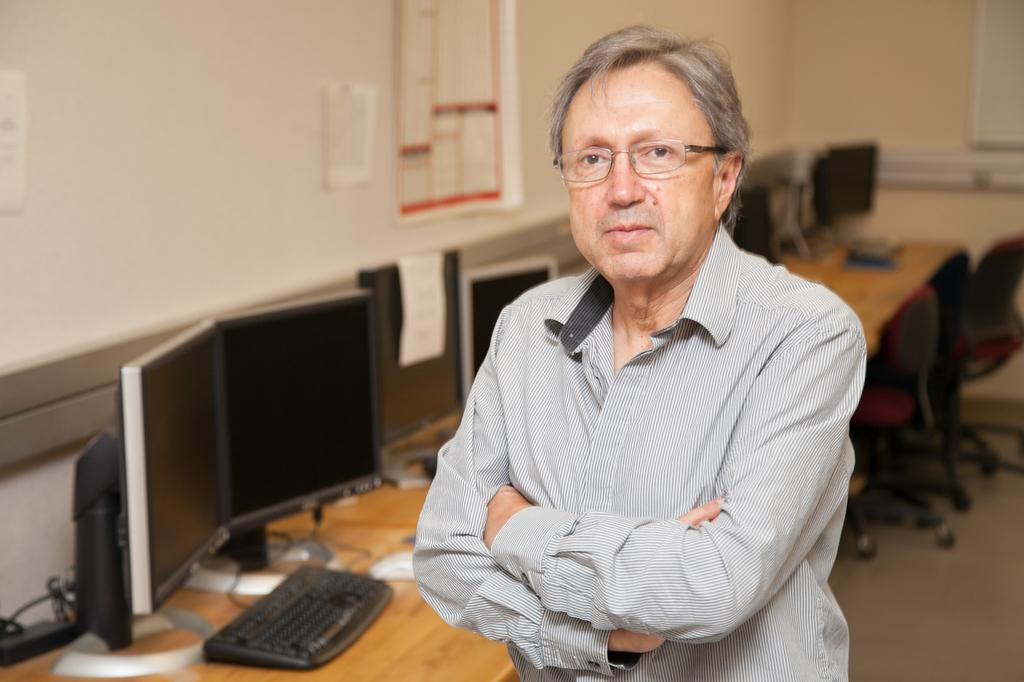What are the people in the image doing? The persons standing on the floor are likely working or interacting with the equipment in the background. What type of equipment can be seen in the background? Monitors, keyboards, tables, chairs, and a board are visible in the background. What type of wall decoration is present in the background? There is a calendar on the wall in the background. Can you see a crown on the head of any person in the image? No, there is no crown visible on anyone's head in the image. What type of paint is being used on the board in the image? There is no paint visible on the board in the image; it appears to be a whiteboard or a similar surface. 